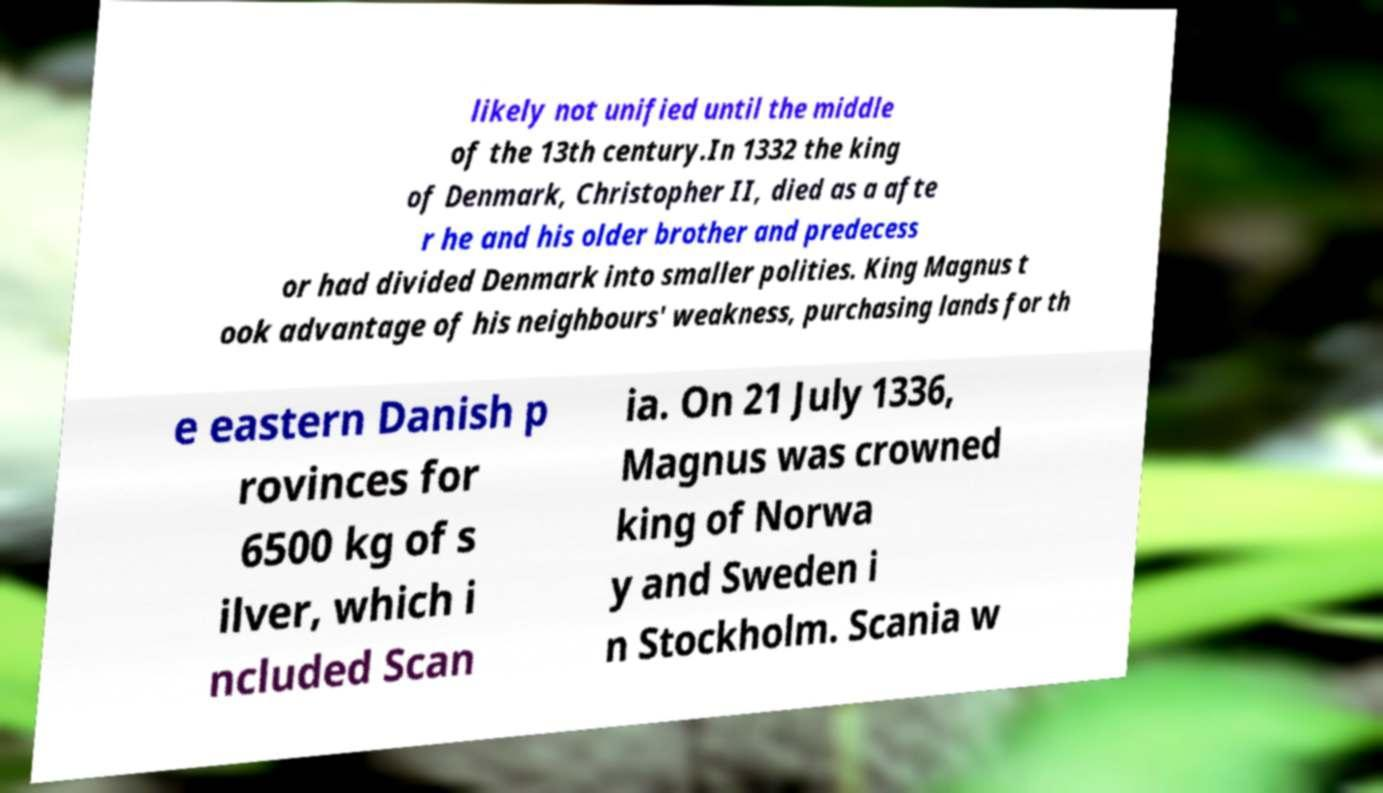Could you assist in decoding the text presented in this image and type it out clearly? likely not unified until the middle of the 13th century.In 1332 the king of Denmark, Christopher II, died as a afte r he and his older brother and predecess or had divided Denmark into smaller polities. King Magnus t ook advantage of his neighbours' weakness, purchasing lands for th e eastern Danish p rovinces for 6500 kg of s ilver, which i ncluded Scan ia. On 21 July 1336, Magnus was crowned king of Norwa y and Sweden i n Stockholm. Scania w 